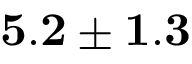Convert formula to latex. <formula><loc_0><loc_0><loc_500><loc_500>{ 5 . 2 \pm 1 . 3 }</formula> 